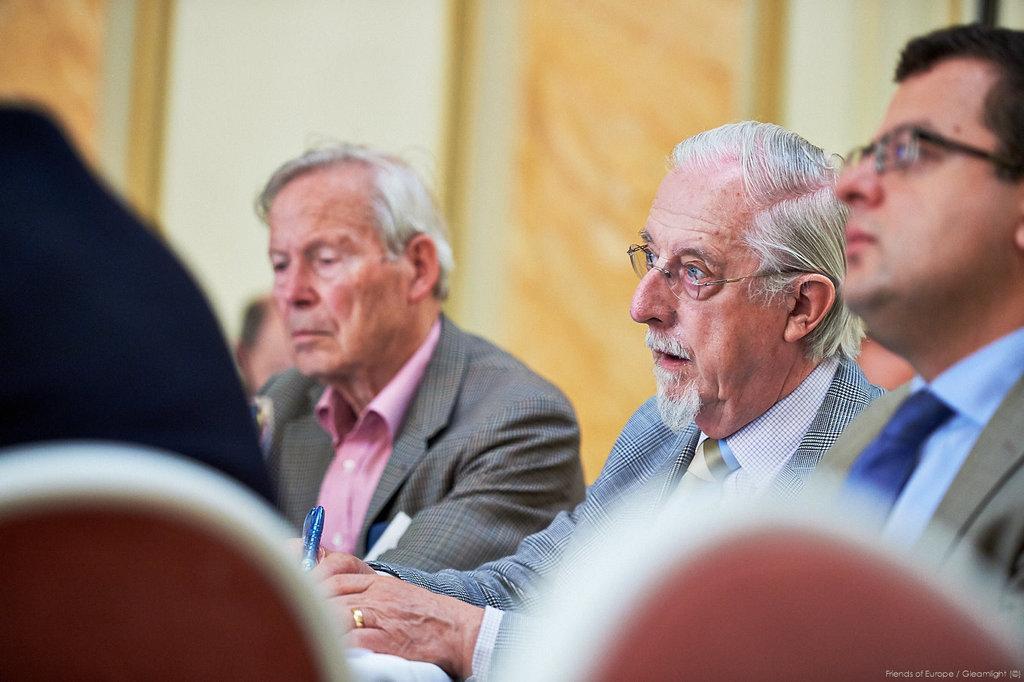In one or two sentences, can you explain what this image depicts? In this image I see 3 men who are wearing suits and I see that this man is holding a thing in his hand and in the background I see the white and orange color wall. 